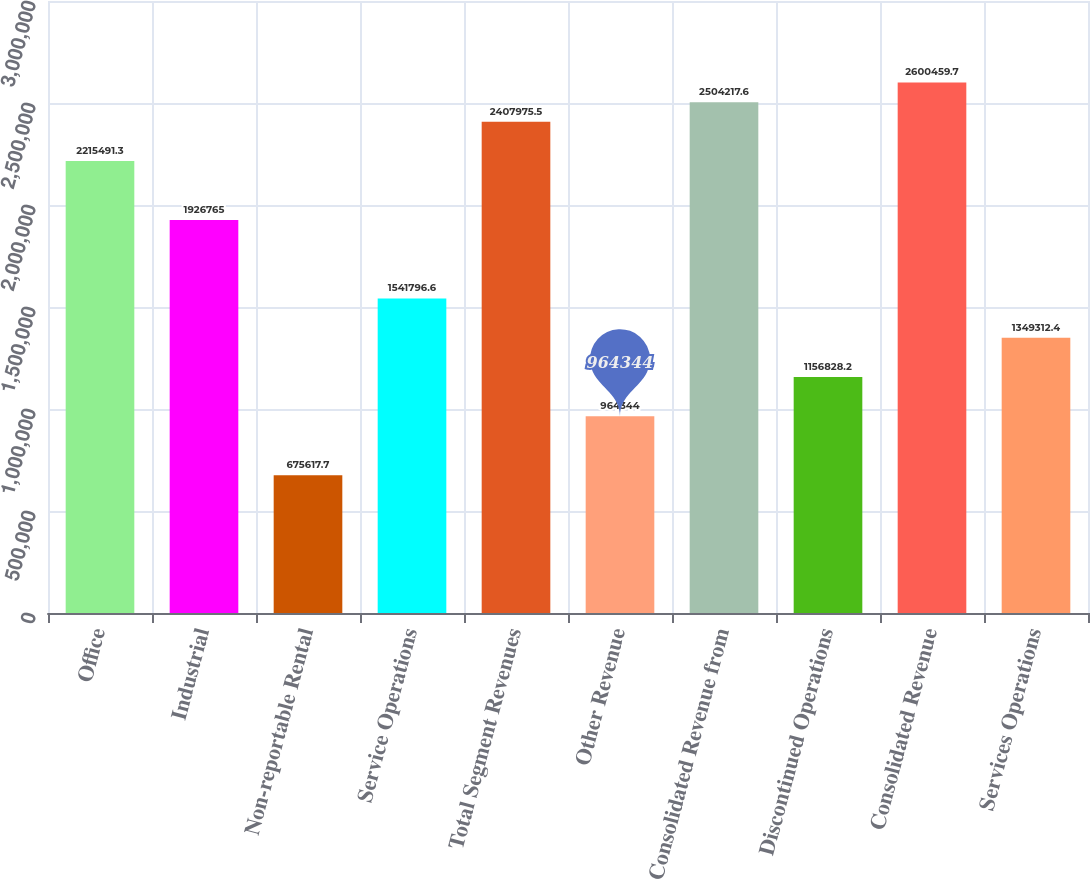<chart> <loc_0><loc_0><loc_500><loc_500><bar_chart><fcel>Office<fcel>Industrial<fcel>Non-reportable Rental<fcel>Service Operations<fcel>Total Segment Revenues<fcel>Other Revenue<fcel>Consolidated Revenue from<fcel>Discontinued Operations<fcel>Consolidated Revenue<fcel>Services Operations<nl><fcel>2.21549e+06<fcel>1.92676e+06<fcel>675618<fcel>1.5418e+06<fcel>2.40798e+06<fcel>964344<fcel>2.50422e+06<fcel>1.15683e+06<fcel>2.60046e+06<fcel>1.34931e+06<nl></chart> 